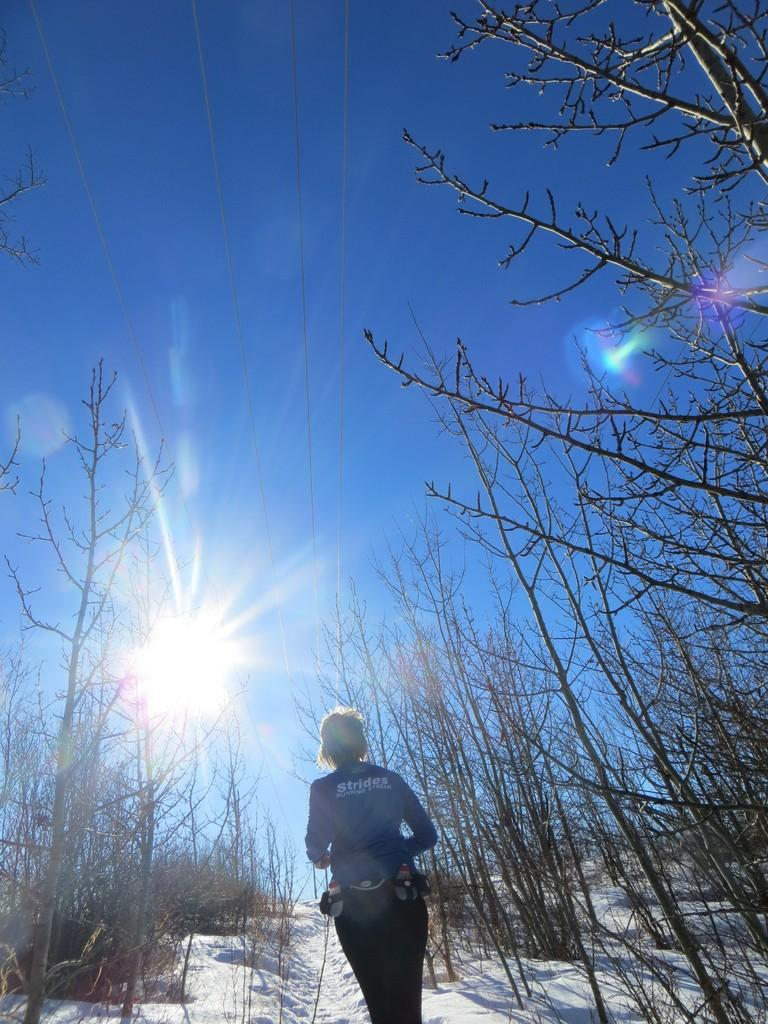Who or what is present in the image? There is a person in the image. What is the person doing in the image? The person is walking on snow. What can be seen on either side of the person? There are dry trees on either side of the person. What is visible in the background of the image? The sky is visible in the image, and clouds are present in the sky. What type of blade is being used by the person to push through the snow? There is no blade present in the image, and the person is not using any tool to push through the snow. 